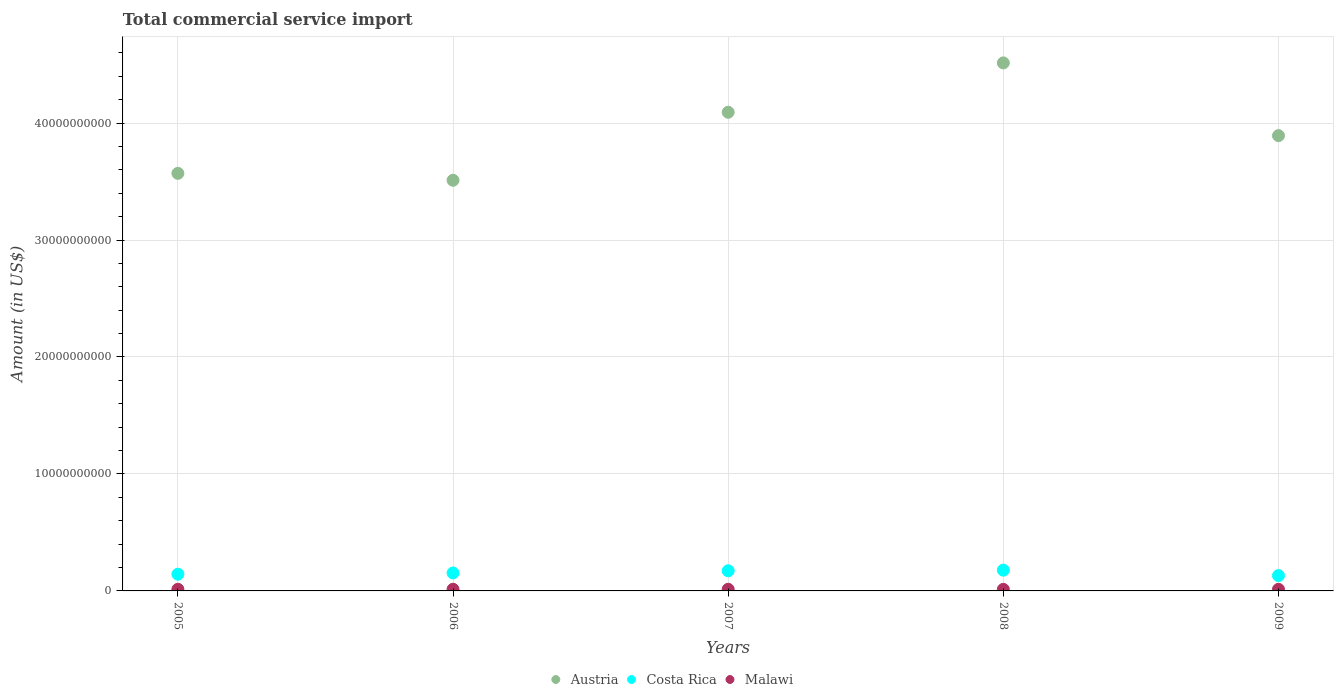What is the total commercial service import in Costa Rica in 2009?
Your answer should be very brief. 1.31e+09. Across all years, what is the maximum total commercial service import in Austria?
Provide a succinct answer. 4.51e+1. Across all years, what is the minimum total commercial service import in Austria?
Provide a short and direct response. 3.51e+1. In which year was the total commercial service import in Malawi minimum?
Give a very brief answer. 2008. What is the total total commercial service import in Costa Rica in the graph?
Make the answer very short. 7.77e+09. What is the difference between the total commercial service import in Costa Rica in 2005 and that in 2006?
Your response must be concise. -1.05e+08. What is the difference between the total commercial service import in Malawi in 2006 and the total commercial service import in Austria in 2007?
Offer a very short reply. -4.08e+1. What is the average total commercial service import in Costa Rica per year?
Ensure brevity in your answer.  1.55e+09. In the year 2009, what is the difference between the total commercial service import in Malawi and total commercial service import in Austria?
Provide a succinct answer. -3.88e+1. What is the ratio of the total commercial service import in Malawi in 2005 to that in 2007?
Keep it short and to the point. 1. Is the total commercial service import in Austria in 2006 less than that in 2008?
Ensure brevity in your answer.  Yes. What is the difference between the highest and the second highest total commercial service import in Malawi?
Provide a succinct answer. 1.30e+06. What is the difference between the highest and the lowest total commercial service import in Costa Rica?
Give a very brief answer. 4.65e+08. Does the total commercial service import in Costa Rica monotonically increase over the years?
Your response must be concise. No. Is the total commercial service import in Austria strictly less than the total commercial service import in Costa Rica over the years?
Keep it short and to the point. No. How many dotlines are there?
Make the answer very short. 3. Are the values on the major ticks of Y-axis written in scientific E-notation?
Give a very brief answer. No. Does the graph contain any zero values?
Provide a succinct answer. No. Where does the legend appear in the graph?
Make the answer very short. Bottom center. How many legend labels are there?
Keep it short and to the point. 3. How are the legend labels stacked?
Offer a very short reply. Horizontal. What is the title of the graph?
Ensure brevity in your answer.  Total commercial service import. What is the label or title of the X-axis?
Provide a succinct answer. Years. What is the label or title of the Y-axis?
Give a very brief answer. Amount (in US$). What is the Amount (in US$) in Austria in 2005?
Keep it short and to the point. 3.57e+1. What is the Amount (in US$) of Costa Rica in 2005?
Your answer should be very brief. 1.43e+09. What is the Amount (in US$) of Malawi in 2005?
Offer a terse response. 1.40e+08. What is the Amount (in US$) in Austria in 2006?
Offer a terse response. 3.51e+1. What is the Amount (in US$) of Costa Rica in 2006?
Offer a terse response. 1.54e+09. What is the Amount (in US$) of Malawi in 2006?
Make the answer very short. 1.42e+08. What is the Amount (in US$) in Austria in 2007?
Keep it short and to the point. 4.09e+1. What is the Amount (in US$) in Costa Rica in 2007?
Provide a succinct answer. 1.72e+09. What is the Amount (in US$) of Malawi in 2007?
Your answer should be compact. 1.41e+08. What is the Amount (in US$) of Austria in 2008?
Your answer should be compact. 4.51e+1. What is the Amount (in US$) of Costa Rica in 2008?
Provide a succinct answer. 1.78e+09. What is the Amount (in US$) in Malawi in 2008?
Your response must be concise. 1.33e+08. What is the Amount (in US$) in Austria in 2009?
Offer a terse response. 3.89e+1. What is the Amount (in US$) of Costa Rica in 2009?
Make the answer very short. 1.31e+09. What is the Amount (in US$) of Malawi in 2009?
Offer a very short reply. 1.36e+08. Across all years, what is the maximum Amount (in US$) in Austria?
Make the answer very short. 4.51e+1. Across all years, what is the maximum Amount (in US$) of Costa Rica?
Give a very brief answer. 1.78e+09. Across all years, what is the maximum Amount (in US$) in Malawi?
Your answer should be very brief. 1.42e+08. Across all years, what is the minimum Amount (in US$) of Austria?
Offer a very short reply. 3.51e+1. Across all years, what is the minimum Amount (in US$) of Costa Rica?
Offer a terse response. 1.31e+09. Across all years, what is the minimum Amount (in US$) of Malawi?
Offer a very short reply. 1.33e+08. What is the total Amount (in US$) in Austria in the graph?
Your answer should be very brief. 1.96e+11. What is the total Amount (in US$) of Costa Rica in the graph?
Ensure brevity in your answer.  7.77e+09. What is the total Amount (in US$) of Malawi in the graph?
Ensure brevity in your answer.  6.92e+08. What is the difference between the Amount (in US$) of Austria in 2005 and that in 2006?
Give a very brief answer. 5.91e+08. What is the difference between the Amount (in US$) of Costa Rica in 2005 and that in 2006?
Your answer should be very brief. -1.05e+08. What is the difference between the Amount (in US$) of Malawi in 2005 and that in 2006?
Offer a terse response. -1.56e+06. What is the difference between the Amount (in US$) of Austria in 2005 and that in 2007?
Provide a short and direct response. -5.22e+09. What is the difference between the Amount (in US$) of Costa Rica in 2005 and that in 2007?
Keep it short and to the point. -2.93e+08. What is the difference between the Amount (in US$) of Malawi in 2005 and that in 2007?
Offer a terse response. -2.56e+05. What is the difference between the Amount (in US$) in Austria in 2005 and that in 2008?
Provide a succinct answer. -9.44e+09. What is the difference between the Amount (in US$) of Costa Rica in 2005 and that in 2008?
Make the answer very short. -3.46e+08. What is the difference between the Amount (in US$) of Malawi in 2005 and that in 2008?
Make the answer very short. 7.25e+06. What is the difference between the Amount (in US$) of Austria in 2005 and that in 2009?
Provide a short and direct response. -3.22e+09. What is the difference between the Amount (in US$) in Costa Rica in 2005 and that in 2009?
Your response must be concise. 1.20e+08. What is the difference between the Amount (in US$) of Malawi in 2005 and that in 2009?
Ensure brevity in your answer.  3.98e+06. What is the difference between the Amount (in US$) of Austria in 2006 and that in 2007?
Ensure brevity in your answer.  -5.81e+09. What is the difference between the Amount (in US$) of Costa Rica in 2006 and that in 2007?
Give a very brief answer. -1.88e+08. What is the difference between the Amount (in US$) in Malawi in 2006 and that in 2007?
Your answer should be very brief. 1.30e+06. What is the difference between the Amount (in US$) of Austria in 2006 and that in 2008?
Make the answer very short. -1.00e+1. What is the difference between the Amount (in US$) in Costa Rica in 2006 and that in 2008?
Your answer should be very brief. -2.40e+08. What is the difference between the Amount (in US$) of Malawi in 2006 and that in 2008?
Keep it short and to the point. 8.81e+06. What is the difference between the Amount (in US$) of Austria in 2006 and that in 2009?
Give a very brief answer. -3.81e+09. What is the difference between the Amount (in US$) of Costa Rica in 2006 and that in 2009?
Provide a succinct answer. 2.25e+08. What is the difference between the Amount (in US$) in Malawi in 2006 and that in 2009?
Your answer should be very brief. 5.54e+06. What is the difference between the Amount (in US$) of Austria in 2007 and that in 2008?
Ensure brevity in your answer.  -4.22e+09. What is the difference between the Amount (in US$) of Costa Rica in 2007 and that in 2008?
Your answer should be compact. -5.24e+07. What is the difference between the Amount (in US$) of Malawi in 2007 and that in 2008?
Offer a terse response. 7.50e+06. What is the difference between the Amount (in US$) in Austria in 2007 and that in 2009?
Your response must be concise. 2.00e+09. What is the difference between the Amount (in US$) in Costa Rica in 2007 and that in 2009?
Your answer should be very brief. 4.13e+08. What is the difference between the Amount (in US$) in Malawi in 2007 and that in 2009?
Your answer should be very brief. 4.24e+06. What is the difference between the Amount (in US$) of Austria in 2008 and that in 2009?
Provide a succinct answer. 6.22e+09. What is the difference between the Amount (in US$) of Costa Rica in 2008 and that in 2009?
Your answer should be compact. 4.65e+08. What is the difference between the Amount (in US$) of Malawi in 2008 and that in 2009?
Make the answer very short. -3.27e+06. What is the difference between the Amount (in US$) in Austria in 2005 and the Amount (in US$) in Costa Rica in 2006?
Your answer should be very brief. 3.42e+1. What is the difference between the Amount (in US$) in Austria in 2005 and the Amount (in US$) in Malawi in 2006?
Provide a succinct answer. 3.56e+1. What is the difference between the Amount (in US$) in Costa Rica in 2005 and the Amount (in US$) in Malawi in 2006?
Provide a short and direct response. 1.29e+09. What is the difference between the Amount (in US$) of Austria in 2005 and the Amount (in US$) of Costa Rica in 2007?
Ensure brevity in your answer.  3.40e+1. What is the difference between the Amount (in US$) of Austria in 2005 and the Amount (in US$) of Malawi in 2007?
Give a very brief answer. 3.56e+1. What is the difference between the Amount (in US$) in Costa Rica in 2005 and the Amount (in US$) in Malawi in 2007?
Keep it short and to the point. 1.29e+09. What is the difference between the Amount (in US$) of Austria in 2005 and the Amount (in US$) of Costa Rica in 2008?
Your answer should be compact. 3.39e+1. What is the difference between the Amount (in US$) in Austria in 2005 and the Amount (in US$) in Malawi in 2008?
Make the answer very short. 3.56e+1. What is the difference between the Amount (in US$) in Costa Rica in 2005 and the Amount (in US$) in Malawi in 2008?
Offer a terse response. 1.30e+09. What is the difference between the Amount (in US$) of Austria in 2005 and the Amount (in US$) of Costa Rica in 2009?
Give a very brief answer. 3.44e+1. What is the difference between the Amount (in US$) of Austria in 2005 and the Amount (in US$) of Malawi in 2009?
Ensure brevity in your answer.  3.56e+1. What is the difference between the Amount (in US$) in Costa Rica in 2005 and the Amount (in US$) in Malawi in 2009?
Offer a terse response. 1.29e+09. What is the difference between the Amount (in US$) of Austria in 2006 and the Amount (in US$) of Costa Rica in 2007?
Offer a terse response. 3.34e+1. What is the difference between the Amount (in US$) in Austria in 2006 and the Amount (in US$) in Malawi in 2007?
Make the answer very short. 3.50e+1. What is the difference between the Amount (in US$) of Costa Rica in 2006 and the Amount (in US$) of Malawi in 2007?
Your answer should be very brief. 1.39e+09. What is the difference between the Amount (in US$) of Austria in 2006 and the Amount (in US$) of Costa Rica in 2008?
Offer a terse response. 3.33e+1. What is the difference between the Amount (in US$) in Austria in 2006 and the Amount (in US$) in Malawi in 2008?
Give a very brief answer. 3.50e+1. What is the difference between the Amount (in US$) in Costa Rica in 2006 and the Amount (in US$) in Malawi in 2008?
Offer a terse response. 1.40e+09. What is the difference between the Amount (in US$) of Austria in 2006 and the Amount (in US$) of Costa Rica in 2009?
Provide a succinct answer. 3.38e+1. What is the difference between the Amount (in US$) in Austria in 2006 and the Amount (in US$) in Malawi in 2009?
Offer a very short reply. 3.50e+1. What is the difference between the Amount (in US$) in Costa Rica in 2006 and the Amount (in US$) in Malawi in 2009?
Provide a succinct answer. 1.40e+09. What is the difference between the Amount (in US$) of Austria in 2007 and the Amount (in US$) of Costa Rica in 2008?
Keep it short and to the point. 3.91e+1. What is the difference between the Amount (in US$) in Austria in 2007 and the Amount (in US$) in Malawi in 2008?
Keep it short and to the point. 4.08e+1. What is the difference between the Amount (in US$) of Costa Rica in 2007 and the Amount (in US$) of Malawi in 2008?
Your answer should be very brief. 1.59e+09. What is the difference between the Amount (in US$) of Austria in 2007 and the Amount (in US$) of Costa Rica in 2009?
Give a very brief answer. 3.96e+1. What is the difference between the Amount (in US$) of Austria in 2007 and the Amount (in US$) of Malawi in 2009?
Your response must be concise. 4.08e+1. What is the difference between the Amount (in US$) of Costa Rica in 2007 and the Amount (in US$) of Malawi in 2009?
Ensure brevity in your answer.  1.59e+09. What is the difference between the Amount (in US$) of Austria in 2008 and the Amount (in US$) of Costa Rica in 2009?
Your response must be concise. 4.38e+1. What is the difference between the Amount (in US$) in Austria in 2008 and the Amount (in US$) in Malawi in 2009?
Provide a short and direct response. 4.50e+1. What is the difference between the Amount (in US$) in Costa Rica in 2008 and the Amount (in US$) in Malawi in 2009?
Offer a terse response. 1.64e+09. What is the average Amount (in US$) in Austria per year?
Ensure brevity in your answer.  3.92e+1. What is the average Amount (in US$) in Costa Rica per year?
Provide a short and direct response. 1.55e+09. What is the average Amount (in US$) in Malawi per year?
Provide a succinct answer. 1.38e+08. In the year 2005, what is the difference between the Amount (in US$) in Austria and Amount (in US$) in Costa Rica?
Your answer should be compact. 3.43e+1. In the year 2005, what is the difference between the Amount (in US$) in Austria and Amount (in US$) in Malawi?
Your answer should be very brief. 3.56e+1. In the year 2005, what is the difference between the Amount (in US$) of Costa Rica and Amount (in US$) of Malawi?
Offer a terse response. 1.29e+09. In the year 2006, what is the difference between the Amount (in US$) of Austria and Amount (in US$) of Costa Rica?
Make the answer very short. 3.36e+1. In the year 2006, what is the difference between the Amount (in US$) of Austria and Amount (in US$) of Malawi?
Offer a terse response. 3.50e+1. In the year 2006, what is the difference between the Amount (in US$) of Costa Rica and Amount (in US$) of Malawi?
Your response must be concise. 1.39e+09. In the year 2007, what is the difference between the Amount (in US$) of Austria and Amount (in US$) of Costa Rica?
Provide a succinct answer. 3.92e+1. In the year 2007, what is the difference between the Amount (in US$) of Austria and Amount (in US$) of Malawi?
Make the answer very short. 4.08e+1. In the year 2007, what is the difference between the Amount (in US$) in Costa Rica and Amount (in US$) in Malawi?
Provide a succinct answer. 1.58e+09. In the year 2008, what is the difference between the Amount (in US$) in Austria and Amount (in US$) in Costa Rica?
Offer a very short reply. 4.34e+1. In the year 2008, what is the difference between the Amount (in US$) in Austria and Amount (in US$) in Malawi?
Keep it short and to the point. 4.50e+1. In the year 2008, what is the difference between the Amount (in US$) in Costa Rica and Amount (in US$) in Malawi?
Provide a succinct answer. 1.64e+09. In the year 2009, what is the difference between the Amount (in US$) in Austria and Amount (in US$) in Costa Rica?
Your answer should be compact. 3.76e+1. In the year 2009, what is the difference between the Amount (in US$) in Austria and Amount (in US$) in Malawi?
Your answer should be very brief. 3.88e+1. In the year 2009, what is the difference between the Amount (in US$) of Costa Rica and Amount (in US$) of Malawi?
Your answer should be very brief. 1.17e+09. What is the ratio of the Amount (in US$) of Austria in 2005 to that in 2006?
Make the answer very short. 1.02. What is the ratio of the Amount (in US$) in Costa Rica in 2005 to that in 2006?
Your response must be concise. 0.93. What is the ratio of the Amount (in US$) of Austria in 2005 to that in 2007?
Ensure brevity in your answer.  0.87. What is the ratio of the Amount (in US$) of Costa Rica in 2005 to that in 2007?
Provide a short and direct response. 0.83. What is the ratio of the Amount (in US$) of Malawi in 2005 to that in 2007?
Your answer should be very brief. 1. What is the ratio of the Amount (in US$) in Austria in 2005 to that in 2008?
Ensure brevity in your answer.  0.79. What is the ratio of the Amount (in US$) in Costa Rica in 2005 to that in 2008?
Offer a very short reply. 0.81. What is the ratio of the Amount (in US$) of Malawi in 2005 to that in 2008?
Ensure brevity in your answer.  1.05. What is the ratio of the Amount (in US$) in Austria in 2005 to that in 2009?
Provide a succinct answer. 0.92. What is the ratio of the Amount (in US$) of Costa Rica in 2005 to that in 2009?
Provide a succinct answer. 1.09. What is the ratio of the Amount (in US$) of Malawi in 2005 to that in 2009?
Offer a very short reply. 1.03. What is the ratio of the Amount (in US$) in Austria in 2006 to that in 2007?
Your response must be concise. 0.86. What is the ratio of the Amount (in US$) in Costa Rica in 2006 to that in 2007?
Your answer should be compact. 0.89. What is the ratio of the Amount (in US$) of Malawi in 2006 to that in 2007?
Make the answer very short. 1.01. What is the ratio of the Amount (in US$) of Austria in 2006 to that in 2008?
Keep it short and to the point. 0.78. What is the ratio of the Amount (in US$) in Costa Rica in 2006 to that in 2008?
Your answer should be very brief. 0.86. What is the ratio of the Amount (in US$) in Malawi in 2006 to that in 2008?
Offer a very short reply. 1.07. What is the ratio of the Amount (in US$) of Austria in 2006 to that in 2009?
Offer a very short reply. 0.9. What is the ratio of the Amount (in US$) in Costa Rica in 2006 to that in 2009?
Give a very brief answer. 1.17. What is the ratio of the Amount (in US$) in Malawi in 2006 to that in 2009?
Offer a very short reply. 1.04. What is the ratio of the Amount (in US$) in Austria in 2007 to that in 2008?
Ensure brevity in your answer.  0.91. What is the ratio of the Amount (in US$) of Costa Rica in 2007 to that in 2008?
Make the answer very short. 0.97. What is the ratio of the Amount (in US$) in Malawi in 2007 to that in 2008?
Provide a succinct answer. 1.06. What is the ratio of the Amount (in US$) in Austria in 2007 to that in 2009?
Your response must be concise. 1.05. What is the ratio of the Amount (in US$) of Costa Rica in 2007 to that in 2009?
Ensure brevity in your answer.  1.32. What is the ratio of the Amount (in US$) of Malawi in 2007 to that in 2009?
Make the answer very short. 1.03. What is the ratio of the Amount (in US$) in Austria in 2008 to that in 2009?
Make the answer very short. 1.16. What is the ratio of the Amount (in US$) in Costa Rica in 2008 to that in 2009?
Your answer should be very brief. 1.36. What is the difference between the highest and the second highest Amount (in US$) of Austria?
Give a very brief answer. 4.22e+09. What is the difference between the highest and the second highest Amount (in US$) in Costa Rica?
Offer a terse response. 5.24e+07. What is the difference between the highest and the second highest Amount (in US$) of Malawi?
Offer a terse response. 1.30e+06. What is the difference between the highest and the lowest Amount (in US$) of Austria?
Make the answer very short. 1.00e+1. What is the difference between the highest and the lowest Amount (in US$) of Costa Rica?
Offer a very short reply. 4.65e+08. What is the difference between the highest and the lowest Amount (in US$) in Malawi?
Make the answer very short. 8.81e+06. 